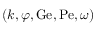Convert formula to latex. <formula><loc_0><loc_0><loc_500><loc_500>( k , \varphi , G e , P e , \omega )</formula> 